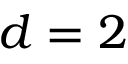<formula> <loc_0><loc_0><loc_500><loc_500>d = 2</formula> 